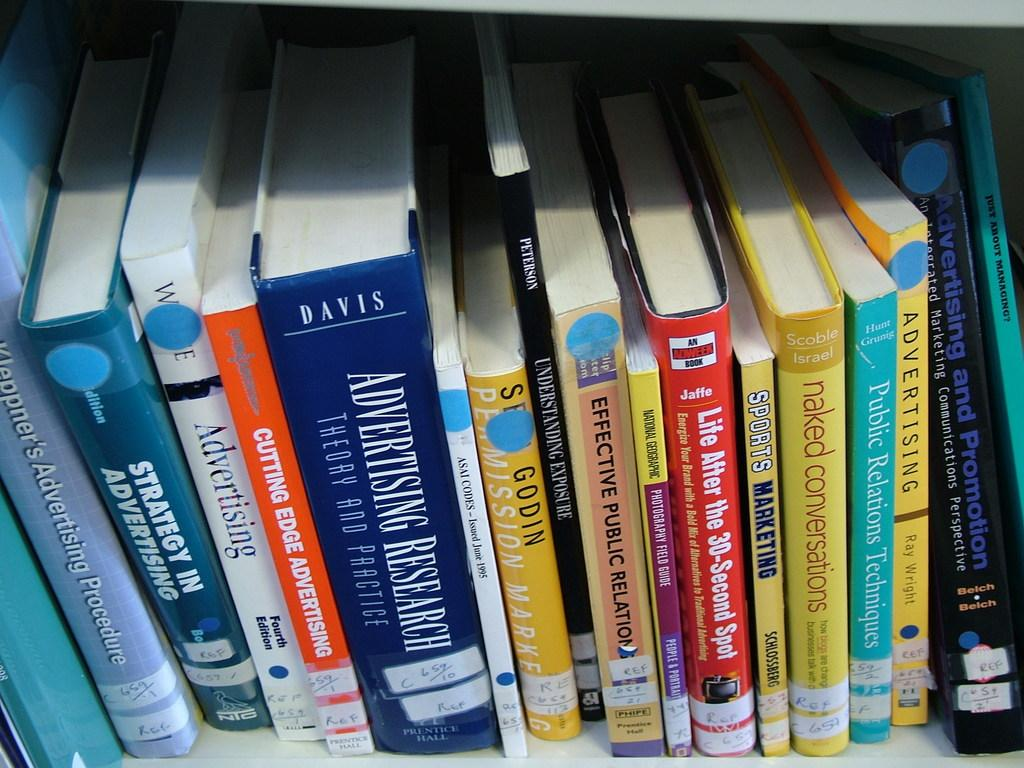<image>
Give a short and clear explanation of the subsequent image. The white book has the word advertising on the spine 